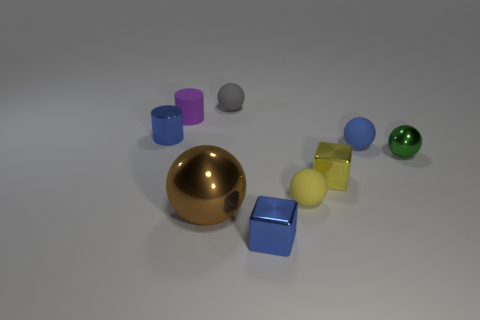Subtract all tiny gray rubber spheres. How many spheres are left? 4 Subtract all green balls. How many balls are left? 4 Subtract 0 purple balls. How many objects are left? 9 Subtract all cubes. How many objects are left? 7 Subtract 1 cubes. How many cubes are left? 1 Subtract all brown cubes. Subtract all gray spheres. How many cubes are left? 2 Subtract all red spheres. How many blue blocks are left? 1 Subtract all red metal spheres. Subtract all blue rubber objects. How many objects are left? 8 Add 6 tiny blue cylinders. How many tiny blue cylinders are left? 7 Add 1 tiny yellow rubber cubes. How many tiny yellow rubber cubes exist? 1 